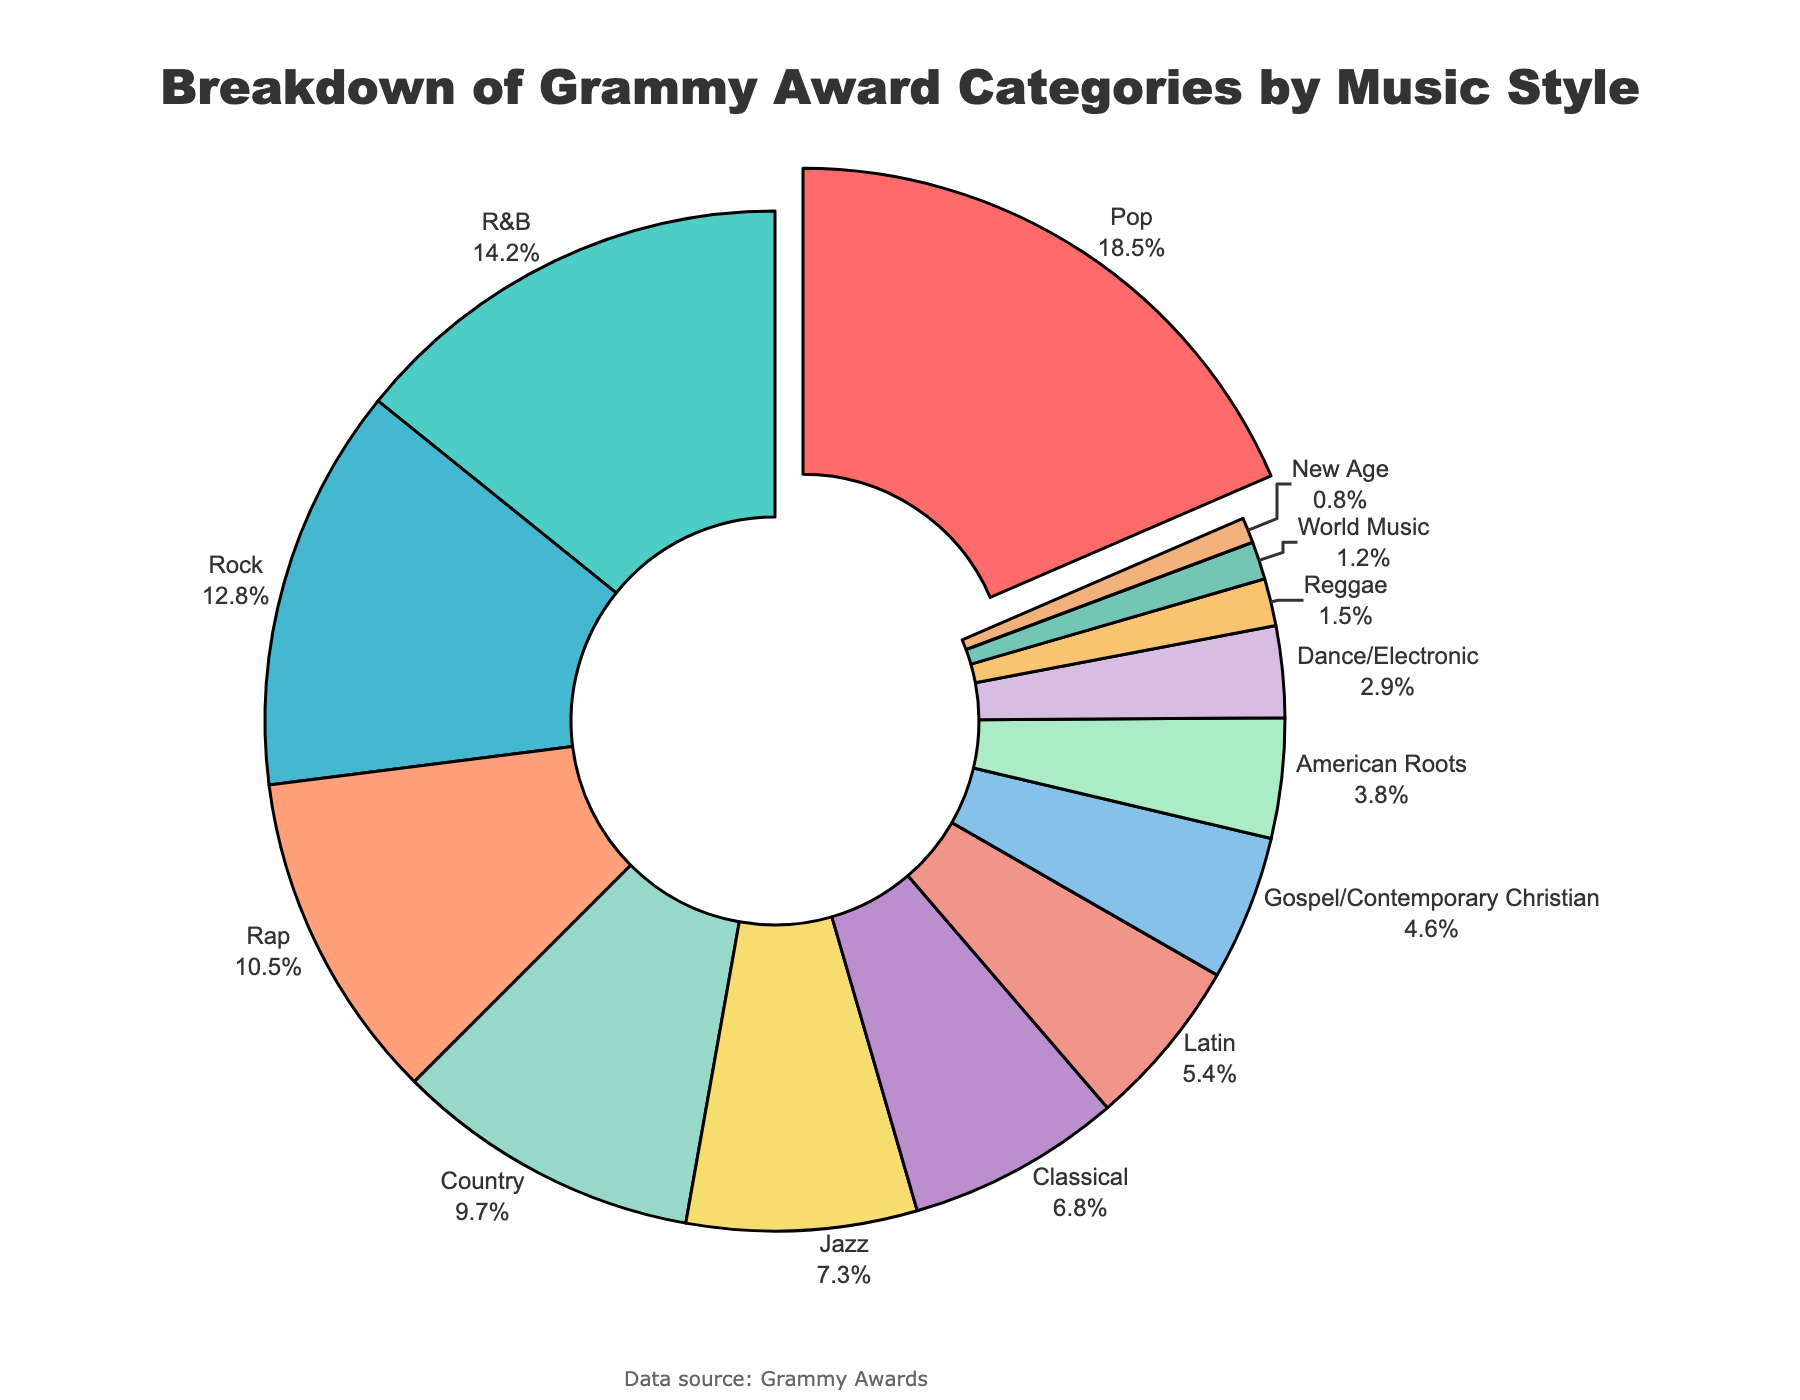What's the most represented music style in the Grammy Award categories? The figure shows the breakdown of Grammy Award categories by music style, and the slice labeled "Pop" has the largest percentage. Hence, Pop is the most represented music style.
Answer: Pop How many music styles represent less than 5% of the Grammy Award categories each? By looking at the figure, we can count the slices with percentages lower than 5%. These are Latin (5.4%), Gospel/Contemporary Christian (4.6%), American Roots (3.8%), Dance/Electronic (2.9%), Reggae (1.5%), World Music (1.2%), and New Age (0.8%). There are 7 music styles in total.
Answer: 7 Which music style has the third highest representation, and what is its percentage? By observing the size of the slices and their labels, we see that the third largest slice corresponds to Rock with a percentage of 12.8%.
Answer: Rock, 12.8% Compare the representation of R&B and Classical categories. Which one is greater, and by what percentage? The figure indicates that R&B has a percentage of 14.2%, and Classical has a percentage of 6.8%. To find out by how much R&B is greater, we subtract the percentage of Classical from that of R&B: 14.2% - 6.8% = 7.4%.
Answer: R&B is greater by 7.4% What is the total percentage representation of Jazz, Country, and Latin categories combined? The percentages for Jazz, Country, and Latin are 7.3%, 9.7%, and 5.4%, respectively. Adding these values together gives 7.3% + 9.7% + 5.4% = 22.4%.
Answer: 22.4% Does Dance/Electronic have a higher representation than Reggae? By comparing the percentages in the figure, Dance/Electronic has 2.9% while Reggae has 1.5%. Thus, Dance/Electronic has a higher representation.
Answer: Yes Arrange Pop, Rap, and Jazz categories in decreasing order of their representation percentages. From the figure, we see that Pop is 18.5%, Rap is 10.5%, and Jazz is 7.3%. Arranging them in decreasing order: 18.5% (Pop), 10.5% (Rap), and 7.3% (Jazz).
Answer: Pop, Rap, Jazz Which music style contributes the smallest percentage, and what is its value? Observing the slices in the figure, New Age has the smallest percentage with a value of 0.8%.
Answer: New Age, 0.8% How much more percentage does Pop have compared to Country? From the figure, Pop has 18.5% and Country has 9.7%. Subtracting the percentages gives 18.5% - 9.7% = 8.8%.
Answer: 8.8% 